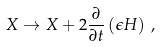<formula> <loc_0><loc_0><loc_500><loc_500>X \rightarrow X + 2 \frac { \partial } { \partial t } \left ( \epsilon H \right ) \, ,</formula> 